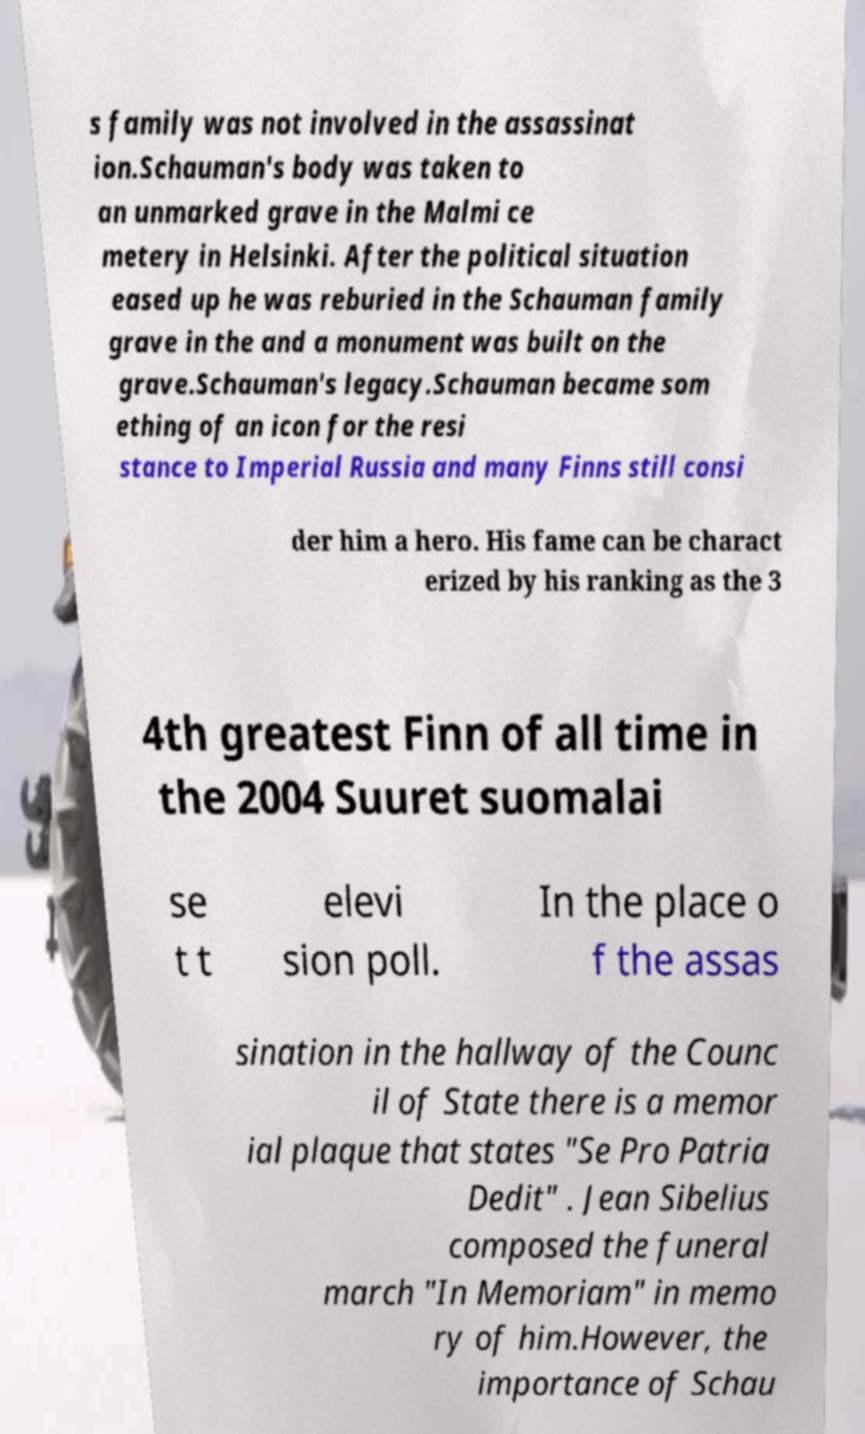I need the written content from this picture converted into text. Can you do that? s family was not involved in the assassinat ion.Schauman's body was taken to an unmarked grave in the Malmi ce metery in Helsinki. After the political situation eased up he was reburied in the Schauman family grave in the and a monument was built on the grave.Schauman's legacy.Schauman became som ething of an icon for the resi stance to Imperial Russia and many Finns still consi der him a hero. His fame can be charact erized by his ranking as the 3 4th greatest Finn of all time in the 2004 Suuret suomalai se t t elevi sion poll. In the place o f the assas sination in the hallway of the Counc il of State there is a memor ial plaque that states "Se Pro Patria Dedit" . Jean Sibelius composed the funeral march "In Memoriam" in memo ry of him.However, the importance of Schau 